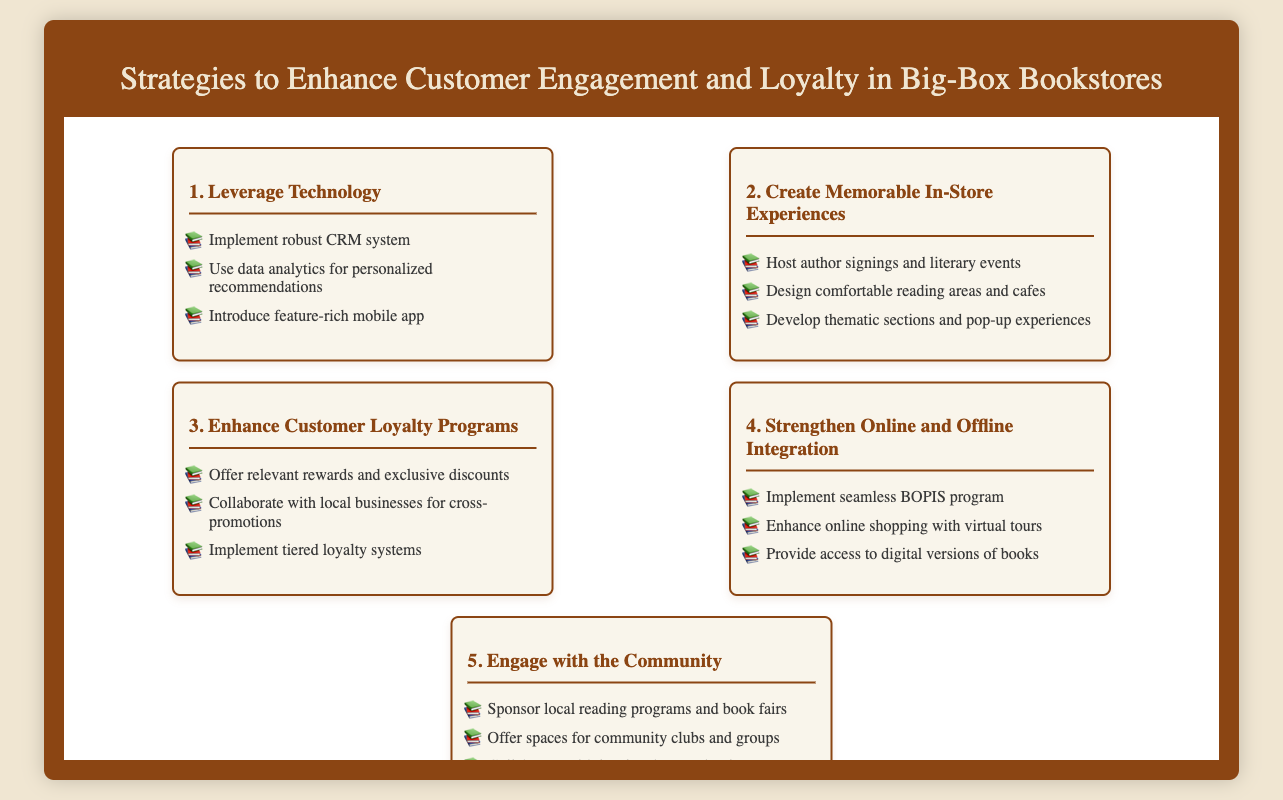What is the first strategy listed? The first strategy in the document focuses on leveraging technology through various methods.
Answer: Leverage Technology How many strategies are presented in total? The document outlines a total of five distinct strategies to enhance customer engagement and loyalty.
Answer: 5 What type of loyalty programs are suggested? Enhancements for loyalty programs include various incentives and collaborative promotions.
Answer: Enhance Customer Loyalty Programs What does BOPIS stand for in the context of this document? BOPIS refers to a seamless shopping program that integrates online and offline experiences.
Answer: Buy Online, Pick Up In Store What type of events does the document suggest hosting to create memorable experiences? The document highlights hosting author signings and literary events as a memorable in-store experience.
Answer: Author signings and literary events What is suggested for community engagement? The suggestions include sponsoring reading programs, which foster better community relations.
Answer: Sponsor local reading programs What kind of system is recommended for customer relationship management? The document suggests implementing a robust CRM system to support customer engagement efforts.
Answer: Robust CRM system How should online shopping be enhanced according to the strategies? Enhancements involve providing virtual tours to improve the online shopping experience.
Answer: Virtual tours 